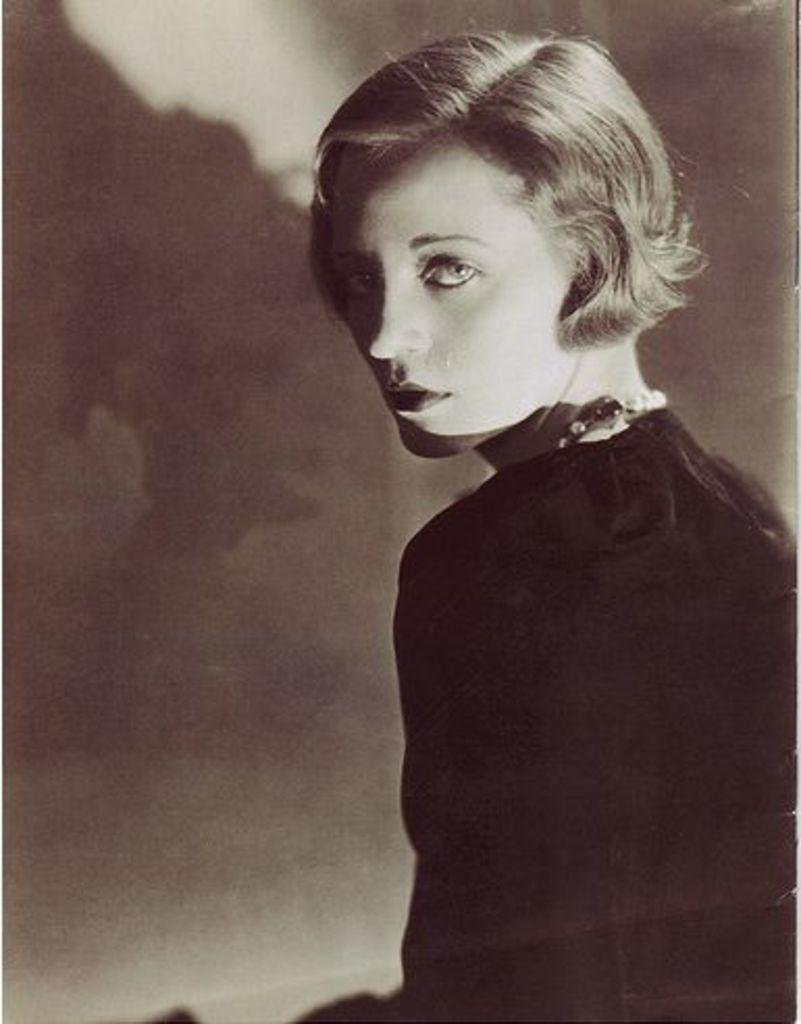Who or what is the main subject of the image? There is a person in the image. What is the person wearing? The person is wearing a dress. Can you describe the background of the image? The background of the image is white and cream in color. How old is the image? The image is old. What flavor of toothpaste is the person using in the image? There is no toothpaste or any indication of toothpaste use in the image. 